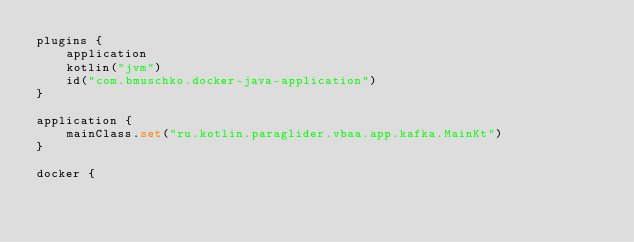Convert code to text. <code><loc_0><loc_0><loc_500><loc_500><_Kotlin_>plugins {
    application
    kotlin("jvm")
    id("com.bmuschko.docker-java-application")
}

application {
    mainClass.set("ru.kotlin.paraglider.vbaa.app.kafka.MainKt")
}

docker {</code> 